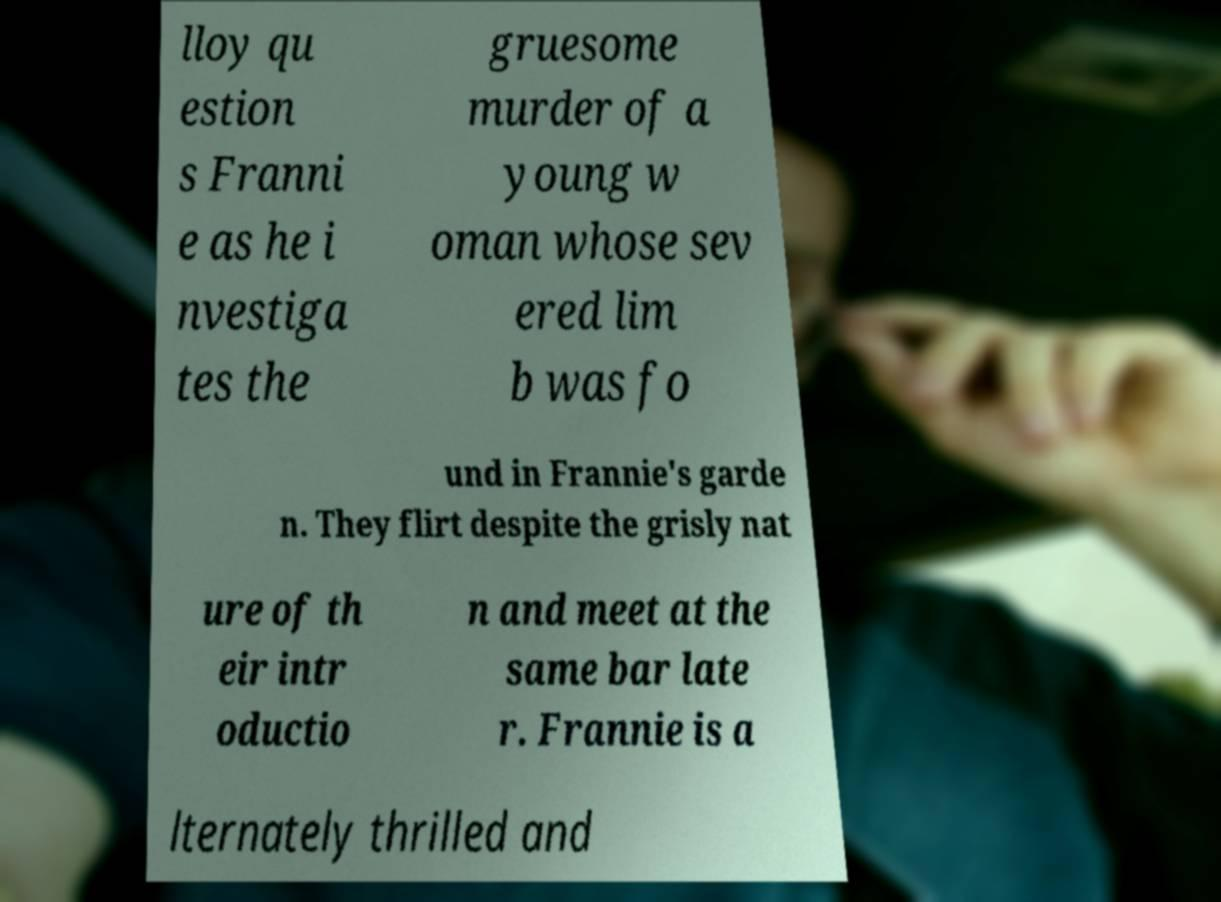There's text embedded in this image that I need extracted. Can you transcribe it verbatim? lloy qu estion s Franni e as he i nvestiga tes the gruesome murder of a young w oman whose sev ered lim b was fo und in Frannie's garde n. They flirt despite the grisly nat ure of th eir intr oductio n and meet at the same bar late r. Frannie is a lternately thrilled and 